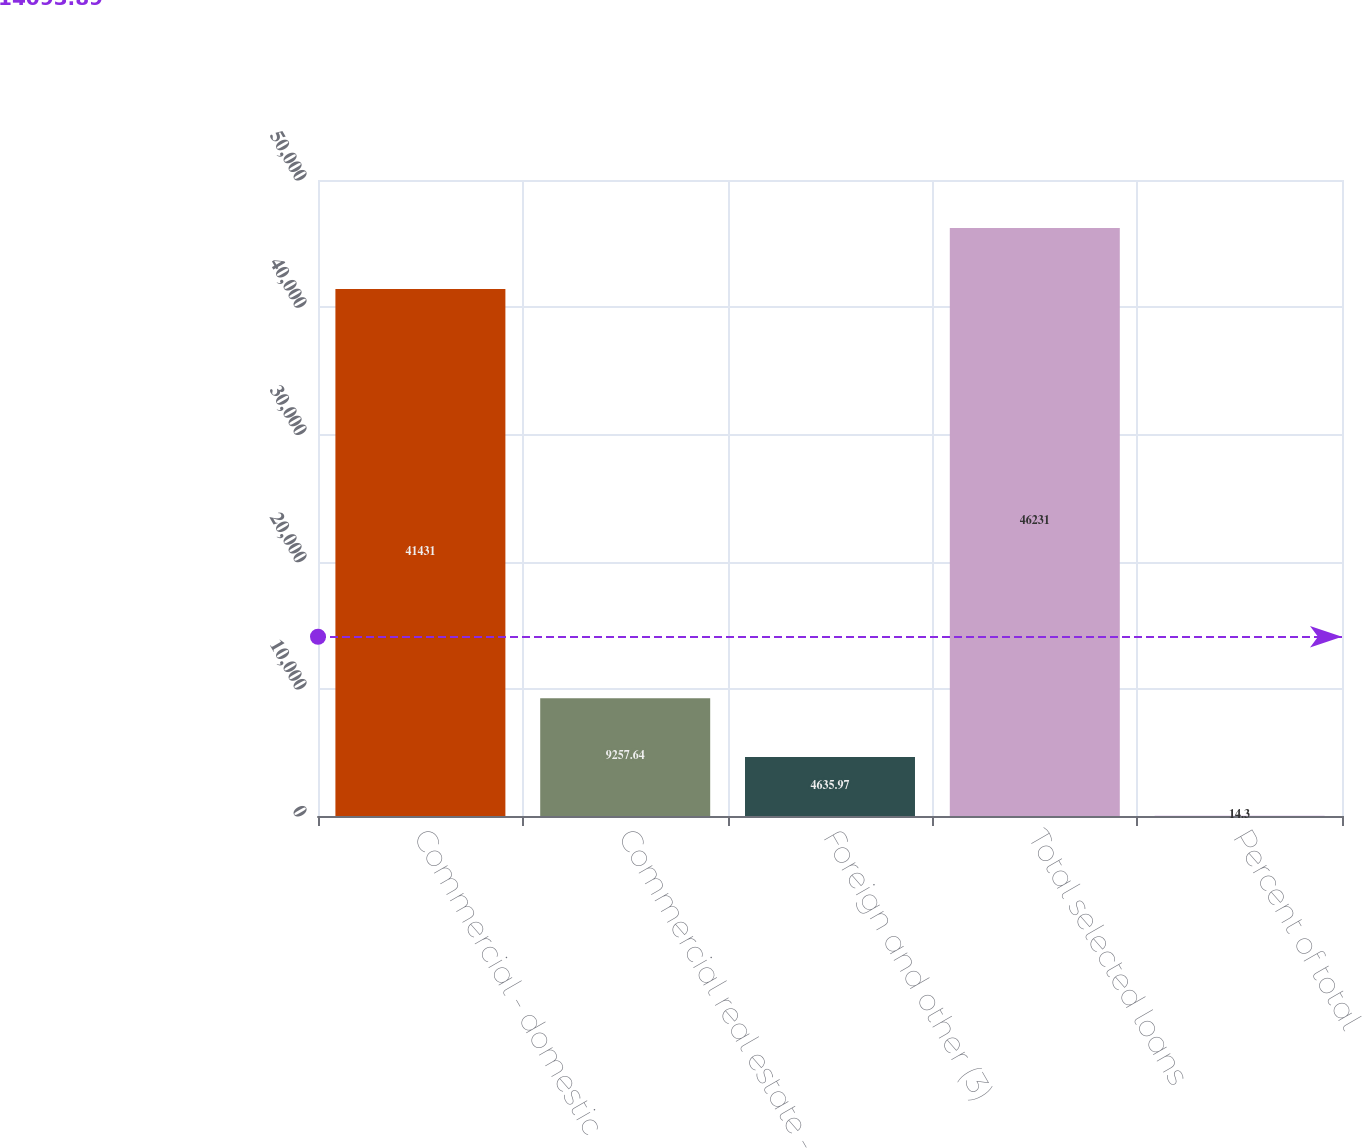<chart> <loc_0><loc_0><loc_500><loc_500><bar_chart><fcel>Commercial - domestic<fcel>Commercial real estate -<fcel>Foreign and other (3)<fcel>Total selected loans<fcel>Percent of total<nl><fcel>41431<fcel>9257.64<fcel>4635.97<fcel>46231<fcel>14.3<nl></chart> 